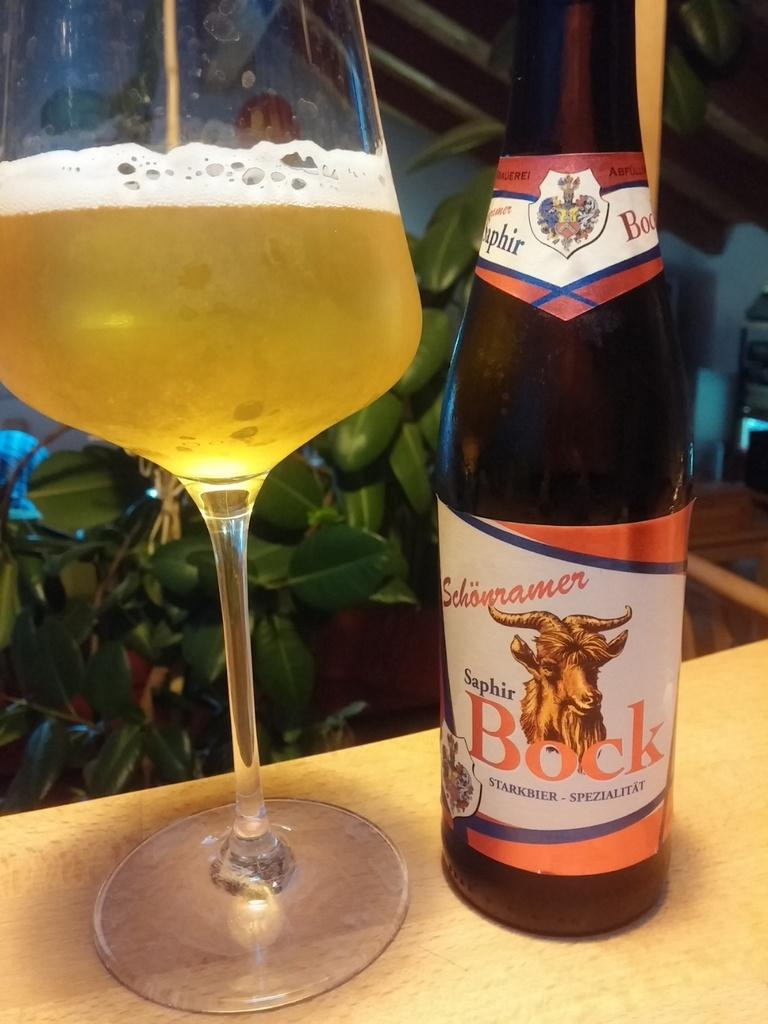<image>
Offer a succinct explanation of the picture presented. A bottle of Saphir Bock beer has a goat on the label. 